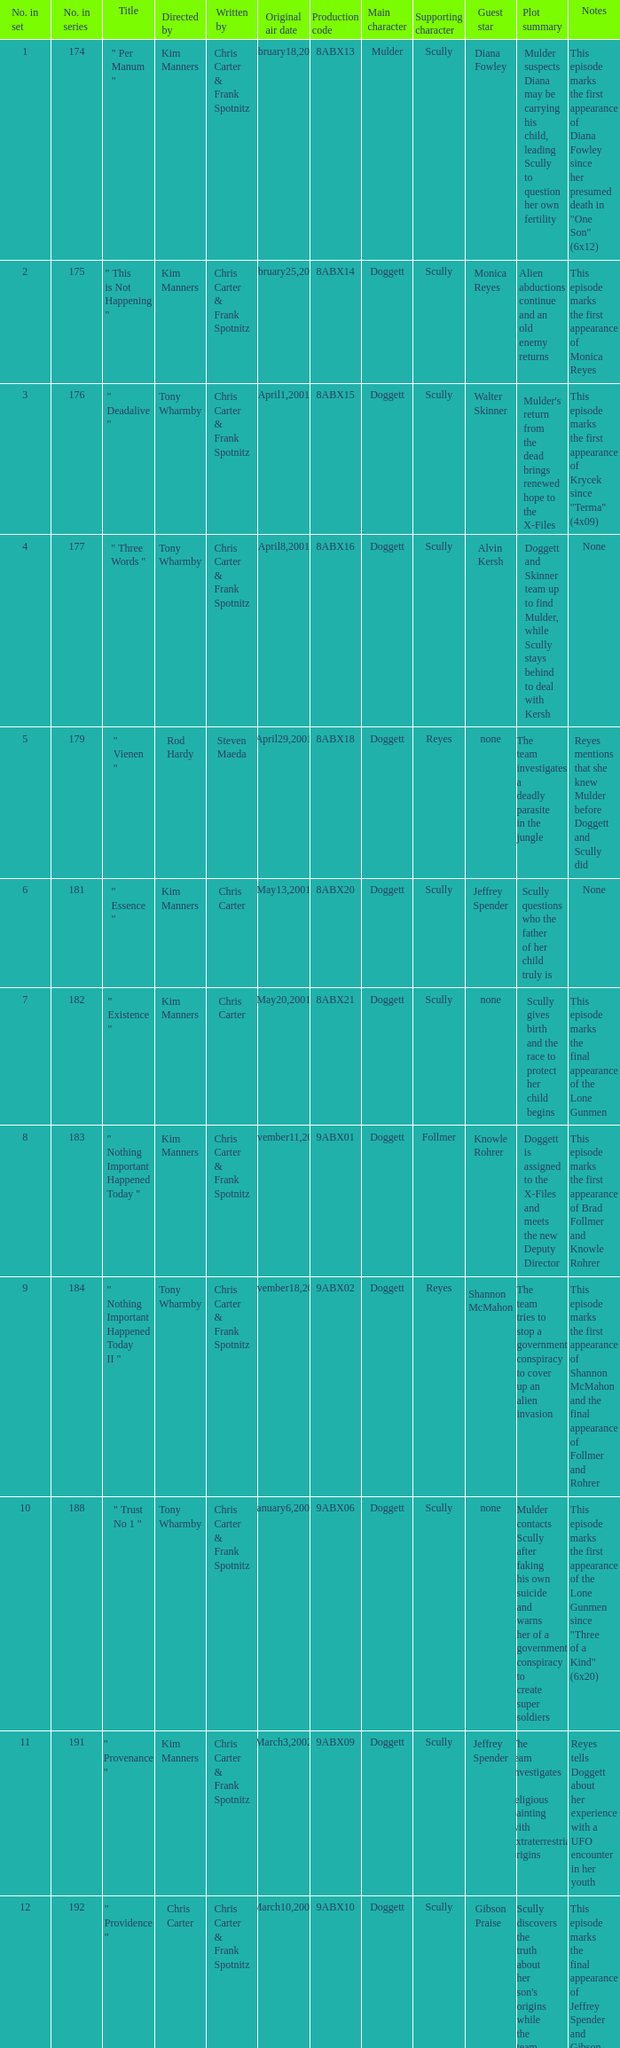The episode with production code 9abx02 was originally aired on what date? November18,2001. 